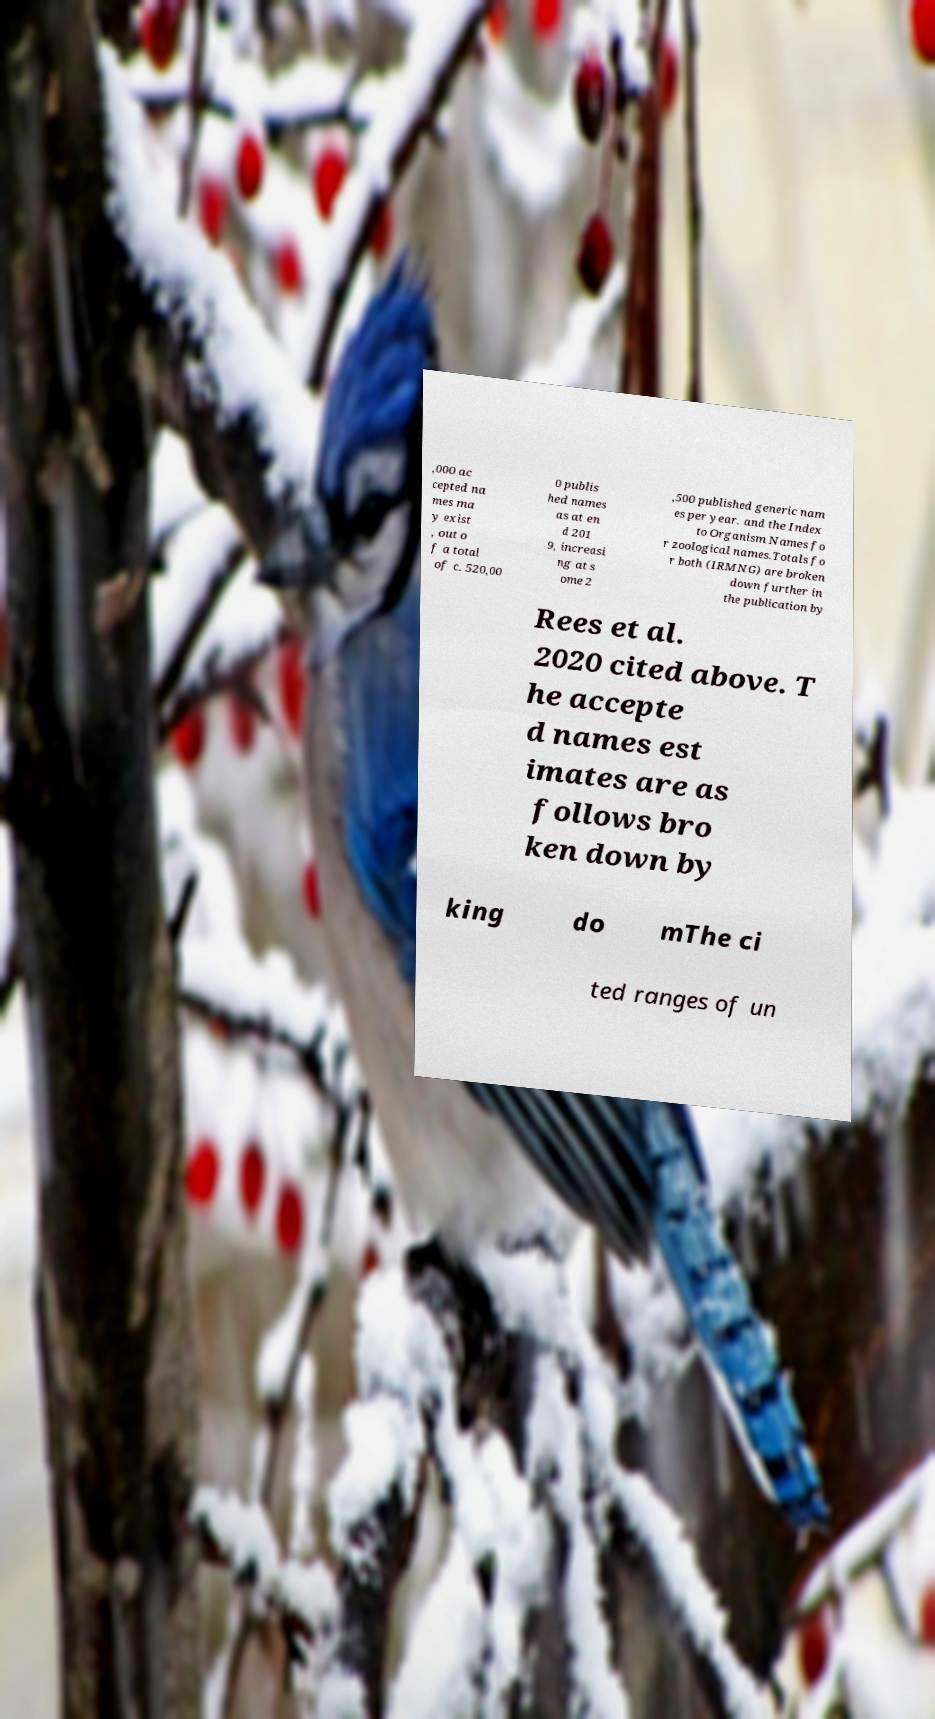Please read and relay the text visible in this image. What does it say? ,000 ac cepted na mes ma y exist , out o f a total of c. 520,00 0 publis hed names as at en d 201 9, increasi ng at s ome 2 ,500 published generic nam es per year. and the Index to Organism Names fo r zoological names.Totals fo r both (IRMNG) are broken down further in the publication by Rees et al. 2020 cited above. T he accepte d names est imates are as follows bro ken down by king do mThe ci ted ranges of un 